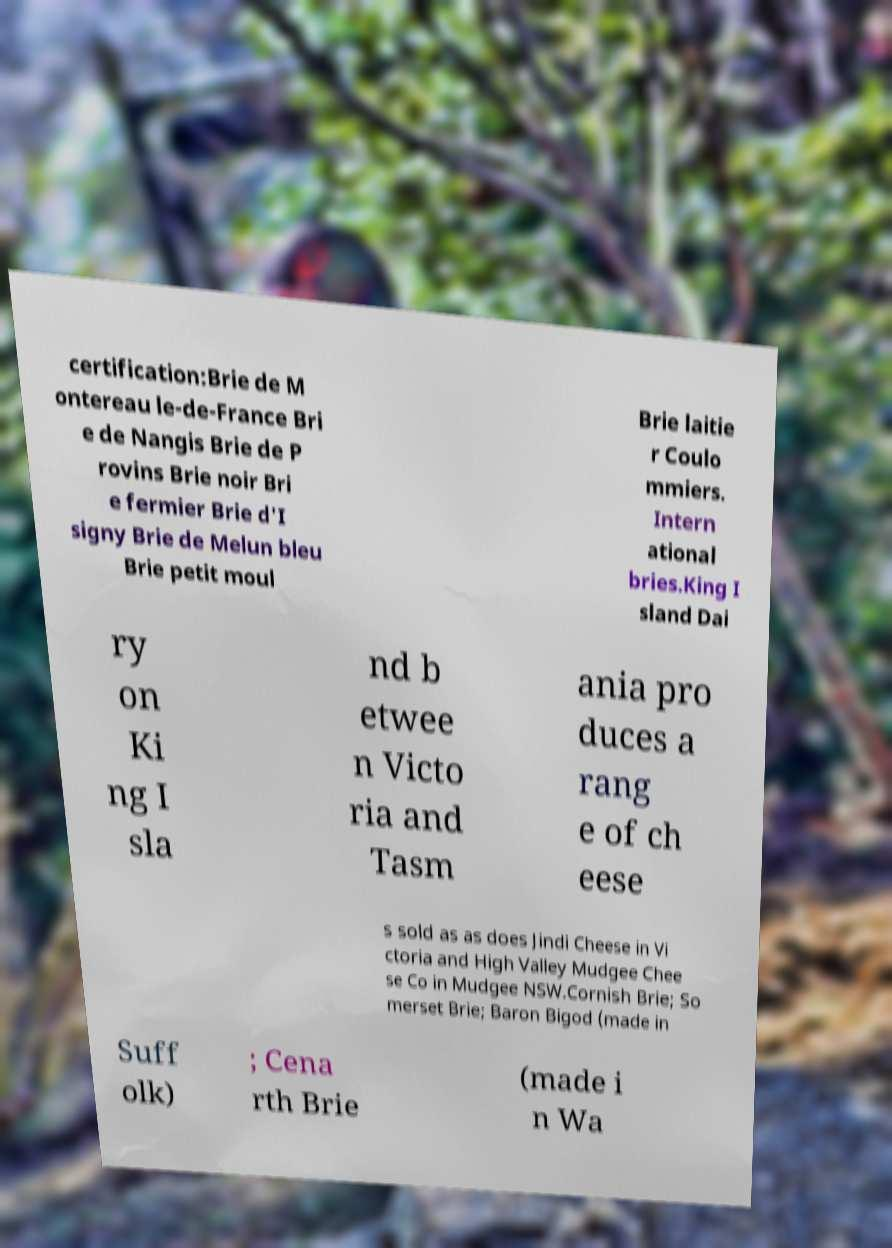Please identify and transcribe the text found in this image. certification:Brie de M ontereau le-de-France Bri e de Nangis Brie de P rovins Brie noir Bri e fermier Brie d'I signy Brie de Melun bleu Brie petit moul Brie laitie r Coulo mmiers. Intern ational bries.King I sland Dai ry on Ki ng I sla nd b etwee n Victo ria and Tasm ania pro duces a rang e of ch eese s sold as as does Jindi Cheese in Vi ctoria and High Valley Mudgee Chee se Co in Mudgee NSW.Cornish Brie; So merset Brie; Baron Bigod (made in Suff olk) ; Cena rth Brie (made i n Wa 